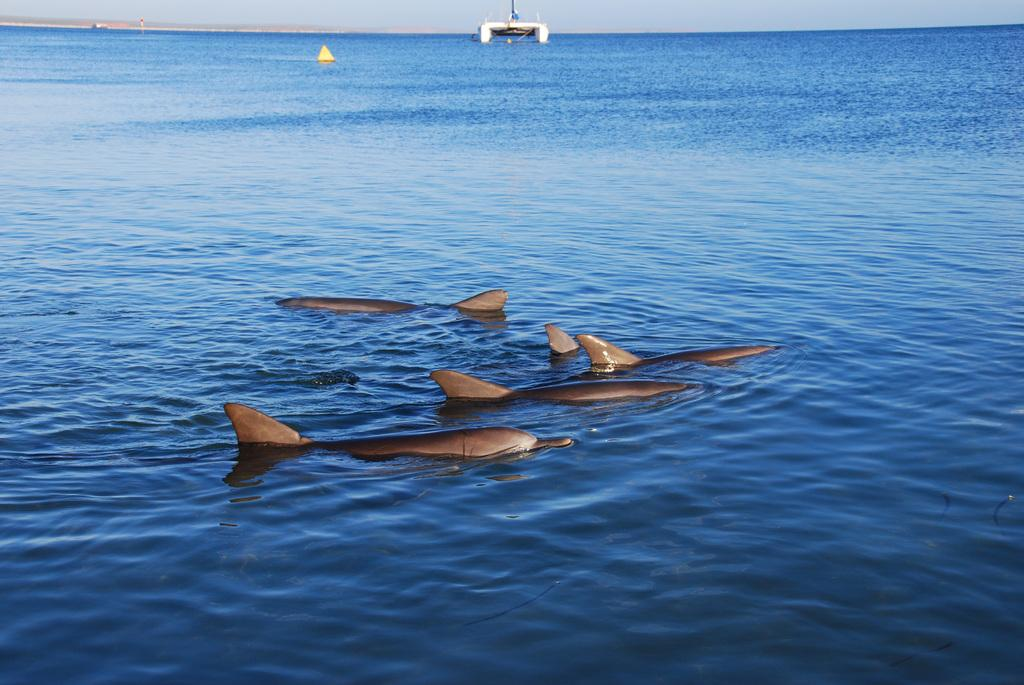What type of animals can be seen in the water in the image? There are fish in the water in the image. What is the primary element in which the fish are situated? The fish are situated in water, which is visible in the image. What type of natural environment is depicted in the image? The image contains a sea. What else can be seen in the water besides the fish? There is an object in the water. What is visible above the water in the image? The sky is visible in the image. What type of winter clothing can be seen on the dogs in the image? There are no dogs present in the image, and therefore no winter clothing can be observed. 